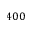Convert formula to latex. <formula><loc_0><loc_0><loc_500><loc_500>4 0 0</formula> 